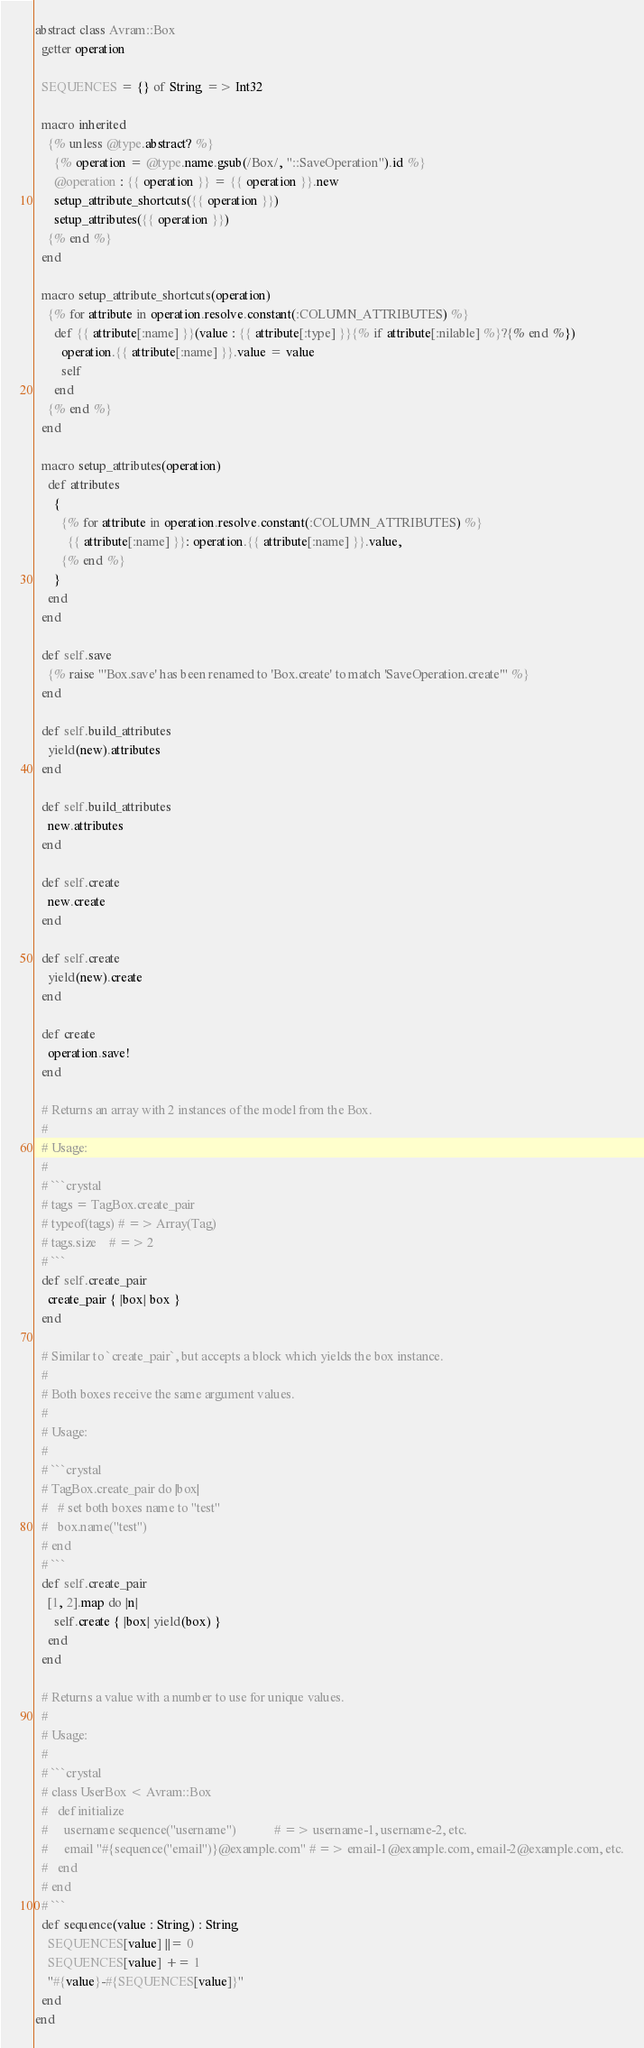Convert code to text. <code><loc_0><loc_0><loc_500><loc_500><_Crystal_>abstract class Avram::Box
  getter operation

  SEQUENCES = {} of String => Int32

  macro inherited
    {% unless @type.abstract? %}
      {% operation = @type.name.gsub(/Box/, "::SaveOperation").id %}
      @operation : {{ operation }} = {{ operation }}.new
      setup_attribute_shortcuts({{ operation }})
      setup_attributes({{ operation }})
    {% end %}
  end

  macro setup_attribute_shortcuts(operation)
    {% for attribute in operation.resolve.constant(:COLUMN_ATTRIBUTES) %}
      def {{ attribute[:name] }}(value : {{ attribute[:type] }}{% if attribute[:nilable] %}?{% end %})
        operation.{{ attribute[:name] }}.value = value
        self
      end
    {% end %}
  end

  macro setup_attributes(operation)
    def attributes
      {
        {% for attribute in operation.resolve.constant(:COLUMN_ATTRIBUTES) %}
          {{ attribute[:name] }}: operation.{{ attribute[:name] }}.value,
        {% end %}
      }
    end
  end

  def self.save
    {% raise "'Box.save' has been renamed to 'Box.create' to match 'SaveOperation.create'" %}
  end

  def self.build_attributes
    yield(new).attributes
  end

  def self.build_attributes
    new.attributes
  end

  def self.create
    new.create
  end

  def self.create
    yield(new).create
  end

  def create
    operation.save!
  end

  # Returns an array with 2 instances of the model from the Box.
  #
  # Usage:
  #
  # ```crystal
  # tags = TagBox.create_pair
  # typeof(tags) # => Array(Tag)
  # tags.size    # => 2
  # ```
  def self.create_pair
    create_pair { |box| box }
  end

  # Similar to `create_pair`, but accepts a block which yields the box instance.
  #
  # Both boxes receive the same argument values.
  #
  # Usage:
  #
  # ```crystal
  # TagBox.create_pair do |box|
  #   # set both boxes name to "test"
  #   box.name("test")
  # end
  # ```
  def self.create_pair
    [1, 2].map do |n|
      self.create { |box| yield(box) }
    end
  end

  # Returns a value with a number to use for unique values.
  #
  # Usage:
  #
  # ```crystal
  # class UserBox < Avram::Box
  #   def initialize
  #     username sequence("username")            # => username-1, username-2, etc.
  #     email "#{sequence("email")}@example.com" # => email-1@example.com, email-2@example.com, etc.
  #   end
  # end
  # ```
  def sequence(value : String) : String
    SEQUENCES[value] ||= 0
    SEQUENCES[value] += 1
    "#{value}-#{SEQUENCES[value]}"
  end
end
</code> 